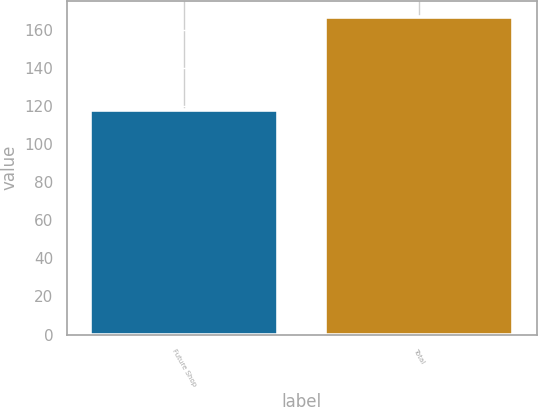Convert chart to OTSL. <chart><loc_0><loc_0><loc_500><loc_500><bar_chart><fcel>Future Shop<fcel>Total<nl><fcel>118<fcel>167<nl></chart> 